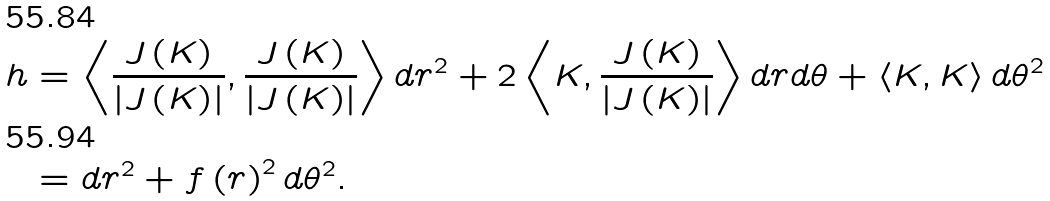<formula> <loc_0><loc_0><loc_500><loc_500>h & = \left \langle \frac { J \left ( K \right ) } { \left | J \left ( K \right ) \right | } , \frac { J \left ( K \right ) } { \left | J \left ( K \right ) \right | } \right \rangle d r ^ { 2 } + 2 \left \langle K , \frac { J \left ( K \right ) } { \left | J \left ( K \right ) \right | } \right \rangle d r d \theta + \left \langle K , K \right \rangle d \theta ^ { 2 } \\ & = d r ^ { 2 } + f \left ( r \right ) ^ { 2 } d \theta ^ { 2 } .</formula> 